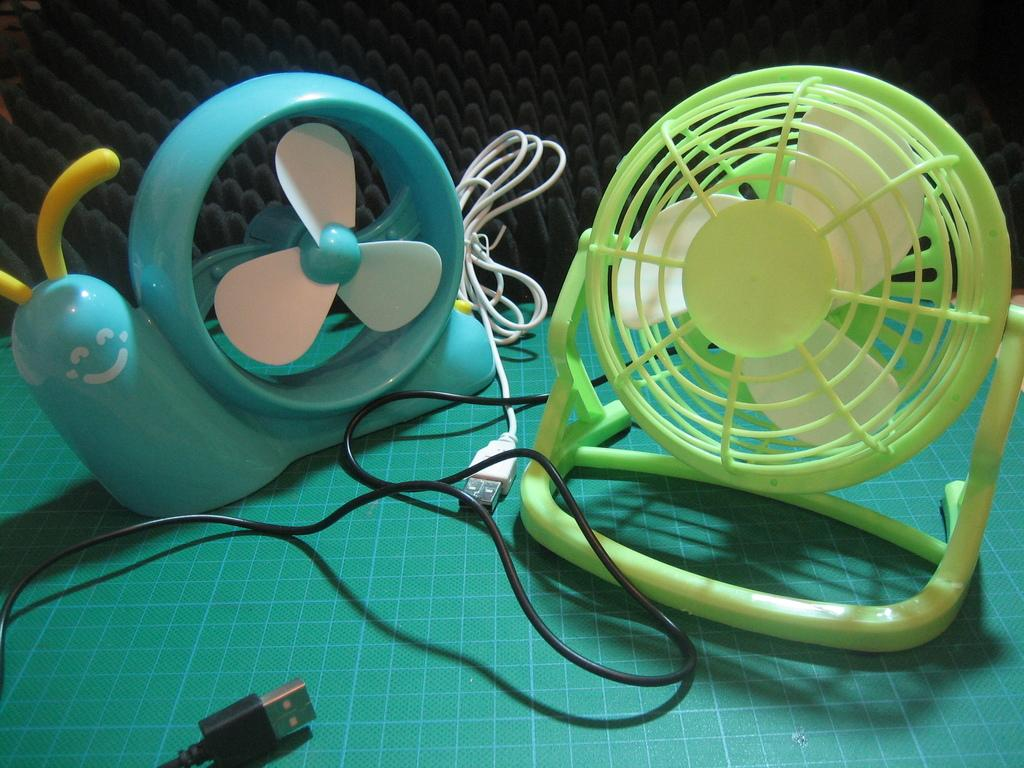What type of objects are on the table in the image? There are toy fans and a cloth on the table in the image. What else can be seen in the image besides the objects on the table? There are wires visible in the image. What is the color of the object in the background of the image? There is a black color object in the background of the image. What type of account does the writer have in the image? There is no writer or account present in the image. What is the writer using the pail for in the image? There is no writer or pail present in the image. 